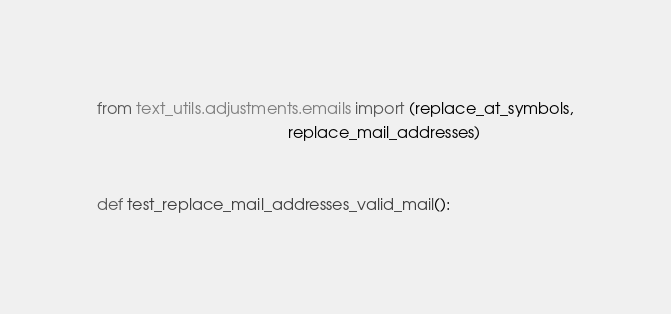Convert code to text. <code><loc_0><loc_0><loc_500><loc_500><_Python_>from text_utils.adjustments.emails import (replace_at_symbols,
                                           replace_mail_addresses)


def test_replace_mail_addresses_valid_mail():</code> 